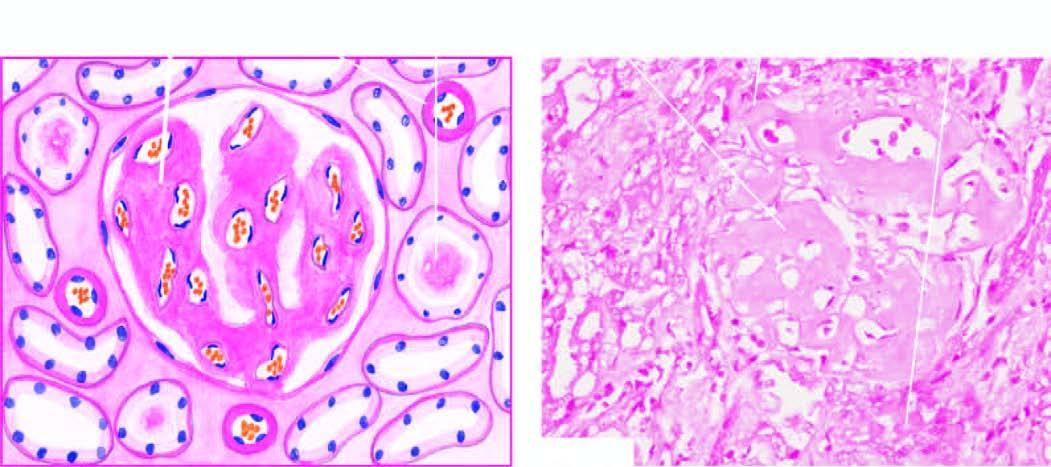where are the deposits producing atrophic tubules present?
Answer the question using a single word or phrase. Peritubular connective tissue 